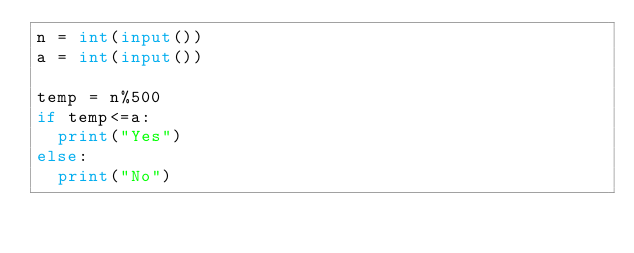Convert code to text. <code><loc_0><loc_0><loc_500><loc_500><_Python_>n = int(input())
a = int(input())

temp = n%500
if temp<=a:
  print("Yes")
else:
  print("No")</code> 